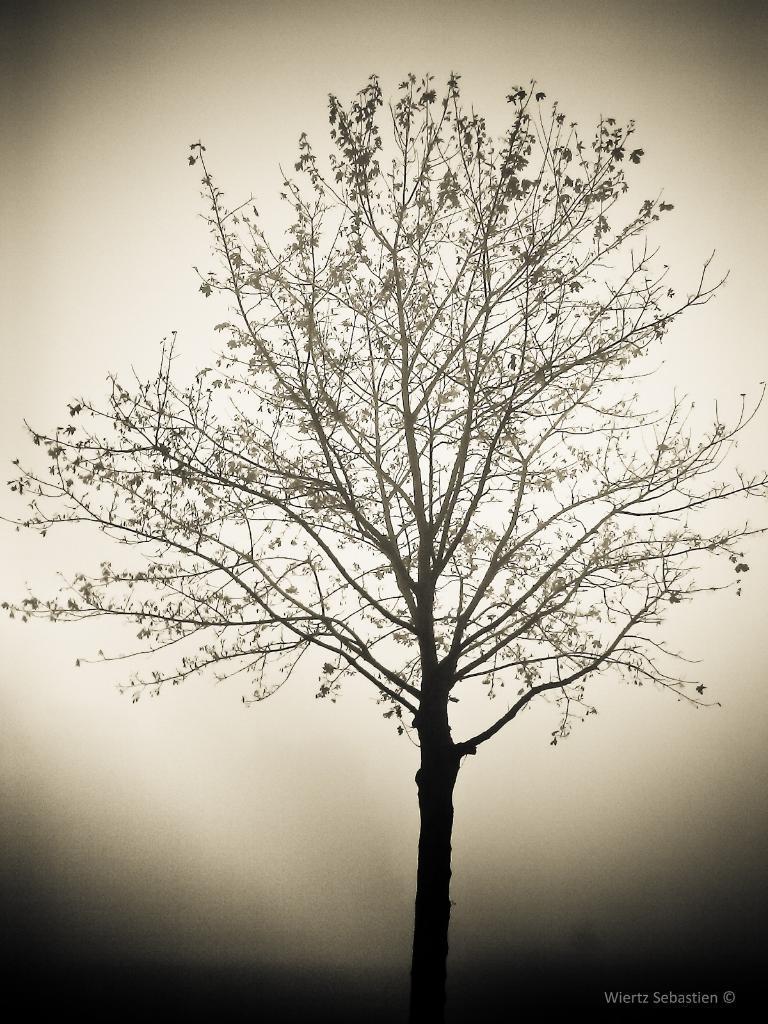Can you describe this image briefly? It is an edited image. I can see a tree with branches and leaves. At the bottom right corner of the image, this is the watermark. 